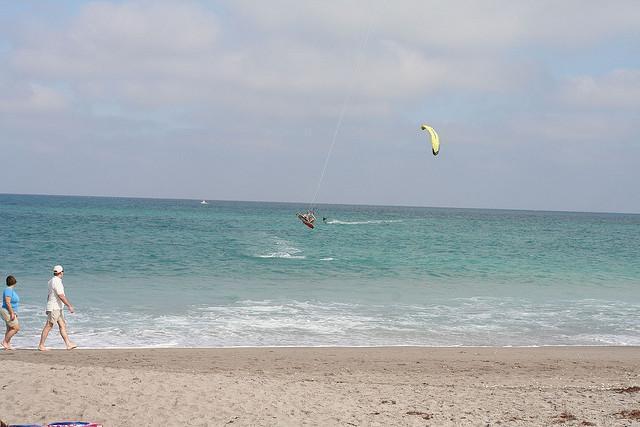How many people are walking on the beach?
Give a very brief answer. 2. How many people are in this picture?
Give a very brief answer. 3. How many people are on the beach?
Give a very brief answer. 2. How many bicycles are there?
Give a very brief answer. 0. 